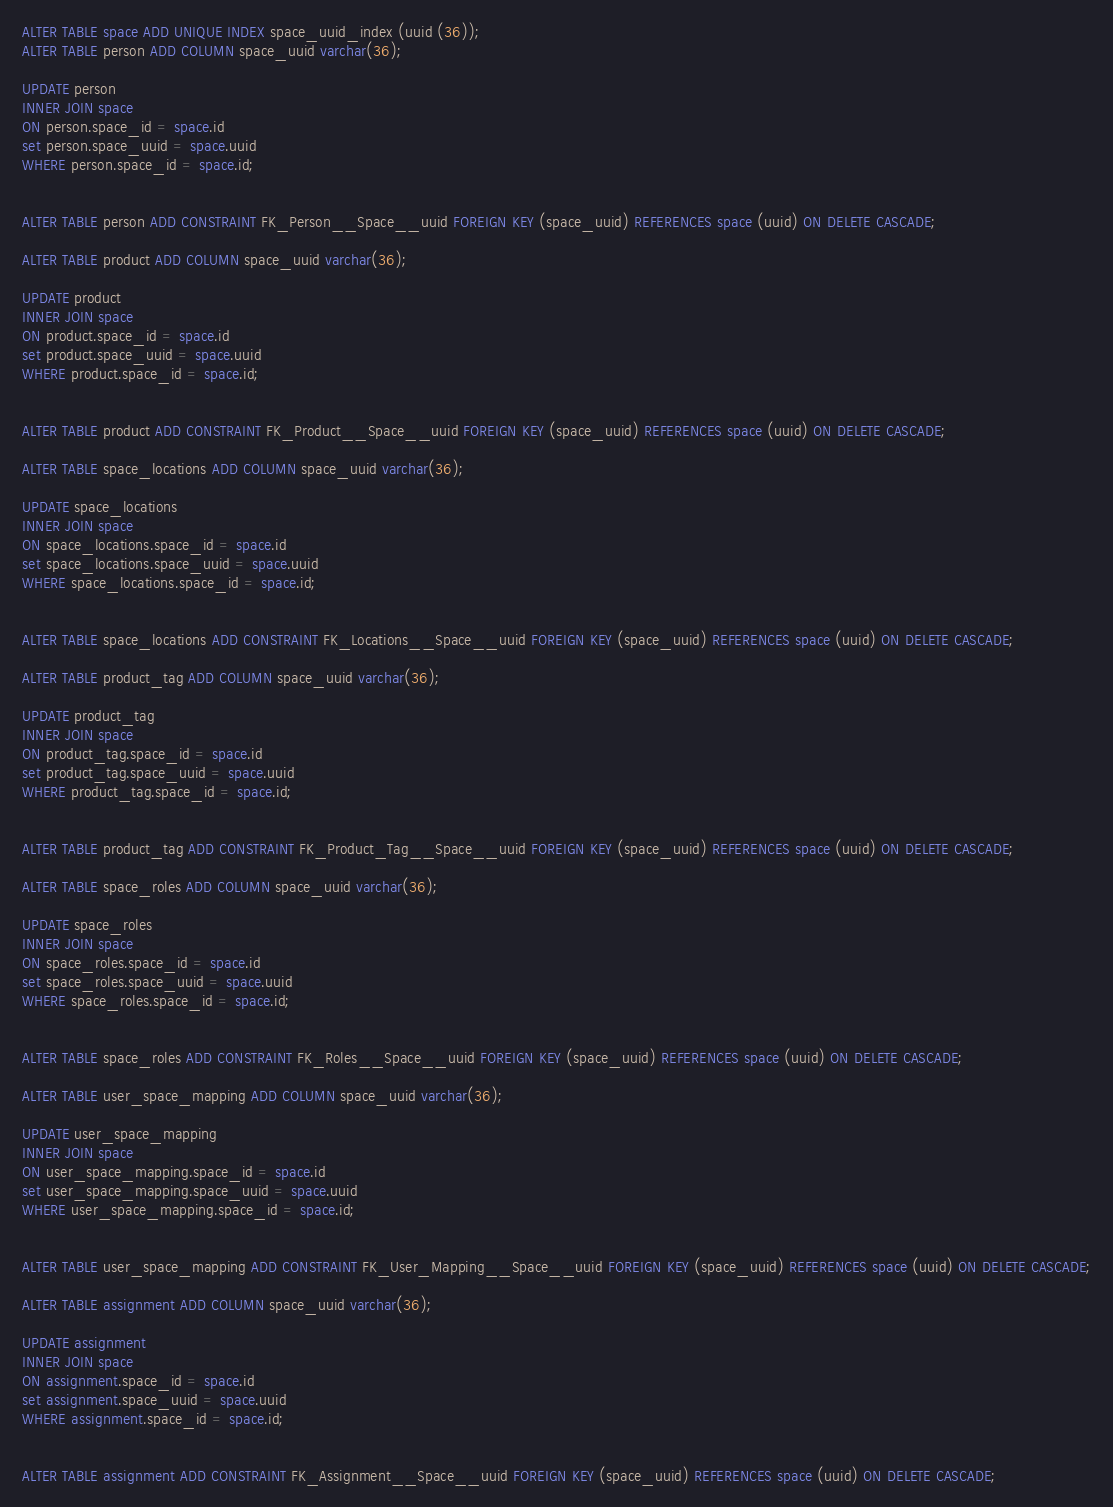<code> <loc_0><loc_0><loc_500><loc_500><_SQL_>ALTER TABLE space ADD UNIQUE INDEX space_uuid_index (uuid (36));
ALTER TABLE person ADD COLUMN space_uuid varchar(36);

UPDATE person
INNER JOIN space
ON person.space_id = space.id
set person.space_uuid = space.uuid
WHERE person.space_id = space.id;


ALTER TABLE person ADD CONSTRAINT FK_Person__Space__uuid FOREIGN KEY (space_uuid) REFERENCES space (uuid) ON DELETE CASCADE;

ALTER TABLE product ADD COLUMN space_uuid varchar(36);

UPDATE product
INNER JOIN space
ON product.space_id = space.id
set product.space_uuid = space.uuid
WHERE product.space_id = space.id;


ALTER TABLE product ADD CONSTRAINT FK_Product__Space__uuid FOREIGN KEY (space_uuid) REFERENCES space (uuid) ON DELETE CASCADE;

ALTER TABLE space_locations ADD COLUMN space_uuid varchar(36);

UPDATE space_locations
INNER JOIN space
ON space_locations.space_id = space.id
set space_locations.space_uuid = space.uuid
WHERE space_locations.space_id = space.id;


ALTER TABLE space_locations ADD CONSTRAINT FK_Locations__Space__uuid FOREIGN KEY (space_uuid) REFERENCES space (uuid) ON DELETE CASCADE;

ALTER TABLE product_tag ADD COLUMN space_uuid varchar(36);

UPDATE product_tag
INNER JOIN space
ON product_tag.space_id = space.id
set product_tag.space_uuid = space.uuid
WHERE product_tag.space_id = space.id;


ALTER TABLE product_tag ADD CONSTRAINT FK_Product_Tag__Space__uuid FOREIGN KEY (space_uuid) REFERENCES space (uuid) ON DELETE CASCADE;

ALTER TABLE space_roles ADD COLUMN space_uuid varchar(36);

UPDATE space_roles
INNER JOIN space
ON space_roles.space_id = space.id
set space_roles.space_uuid = space.uuid
WHERE space_roles.space_id = space.id;


ALTER TABLE space_roles ADD CONSTRAINT FK_Roles__Space__uuid FOREIGN KEY (space_uuid) REFERENCES space (uuid) ON DELETE CASCADE;

ALTER TABLE user_space_mapping ADD COLUMN space_uuid varchar(36);

UPDATE user_space_mapping
INNER JOIN space
ON user_space_mapping.space_id = space.id
set user_space_mapping.space_uuid = space.uuid
WHERE user_space_mapping.space_id = space.id;


ALTER TABLE user_space_mapping ADD CONSTRAINT FK_User_Mapping__Space__uuid FOREIGN KEY (space_uuid) REFERENCES space (uuid) ON DELETE CASCADE;

ALTER TABLE assignment ADD COLUMN space_uuid varchar(36);

UPDATE assignment
INNER JOIN space
ON assignment.space_id = space.id
set assignment.space_uuid = space.uuid
WHERE assignment.space_id = space.id;


ALTER TABLE assignment ADD CONSTRAINT FK_Assignment__Space__uuid FOREIGN KEY (space_uuid) REFERENCES space (uuid) ON DELETE CASCADE;
</code> 